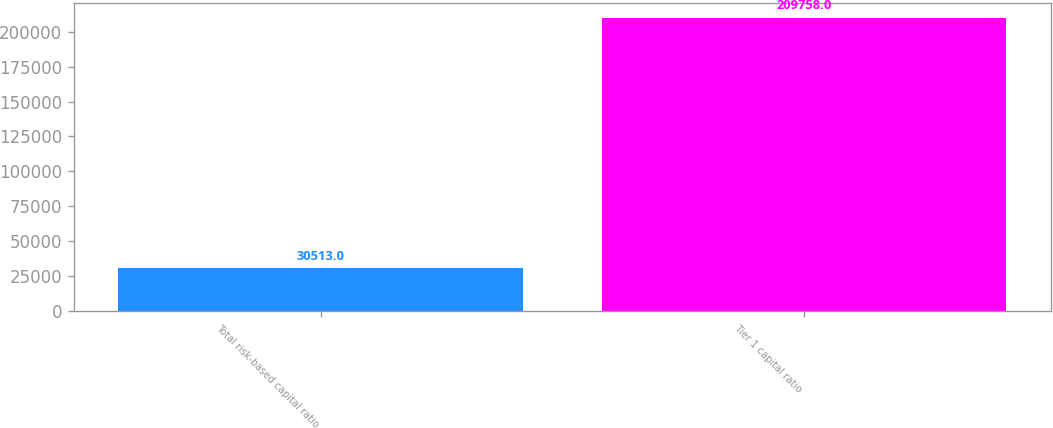Convert chart to OTSL. <chart><loc_0><loc_0><loc_500><loc_500><bar_chart><fcel>Total risk-based capital ratio<fcel>Tier 1 capital ratio<nl><fcel>30513<fcel>209758<nl></chart> 